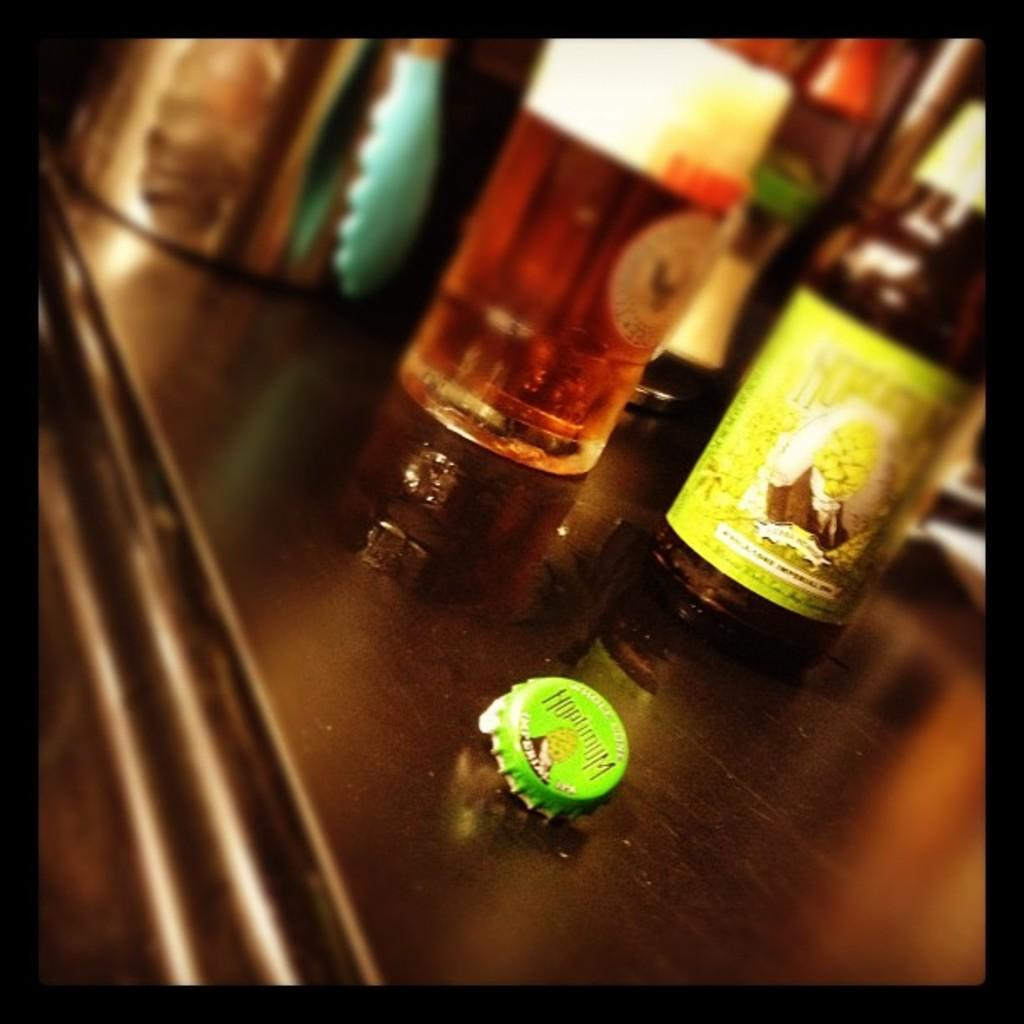What type of furniture is visible in the image? There is a table in the image. What objects are on the table? Bottles are present on the table. What other item can be seen on the table? A cap is on the table. Where was the image taken? The image was taken inside a room. How many sisters are sitting at the table in the image? There are no sisters present in the image; it only shows a table with bottles and a cap. What type of flower is on the table in the image? There is no flower present on the table in the image; it only shows bottles and a cap. a cap. 